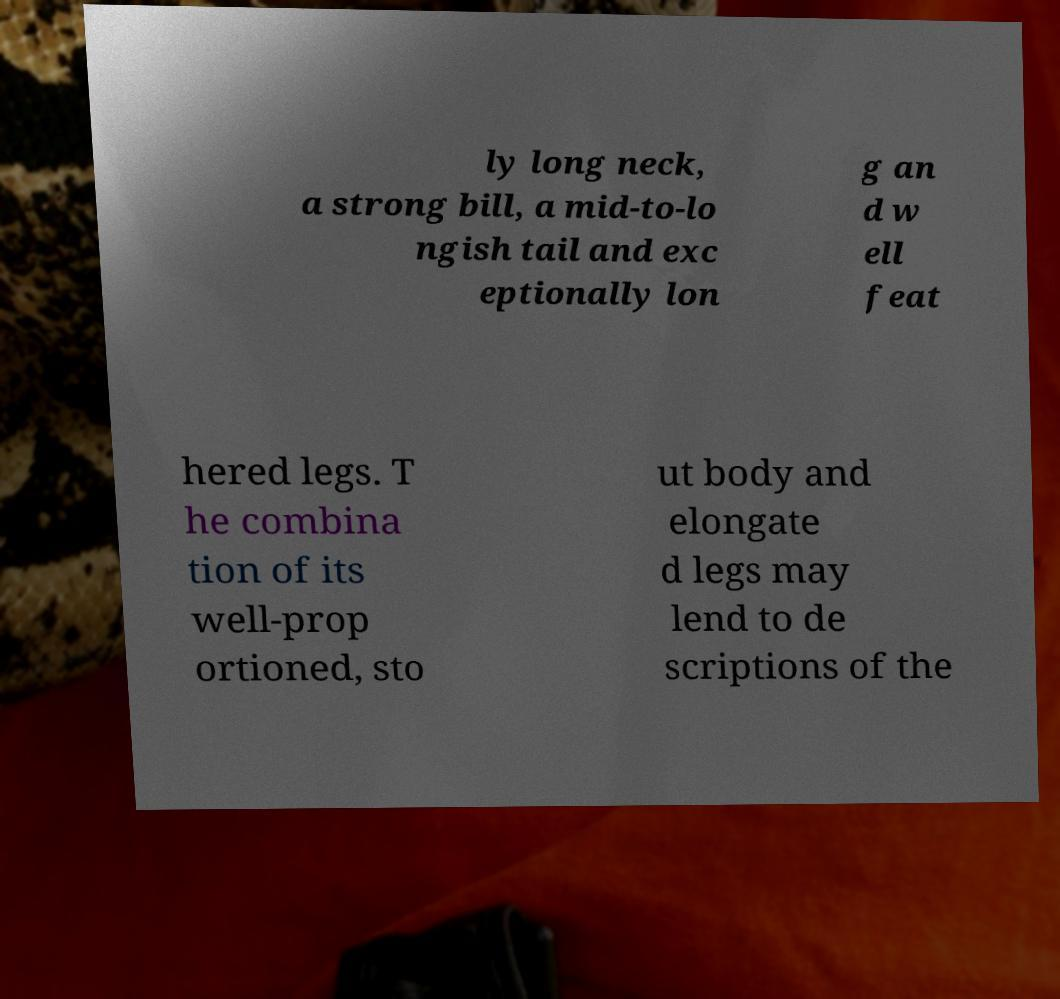For documentation purposes, I need the text within this image transcribed. Could you provide that? ly long neck, a strong bill, a mid-to-lo ngish tail and exc eptionally lon g an d w ell feat hered legs. T he combina tion of its well-prop ortioned, sto ut body and elongate d legs may lend to de scriptions of the 